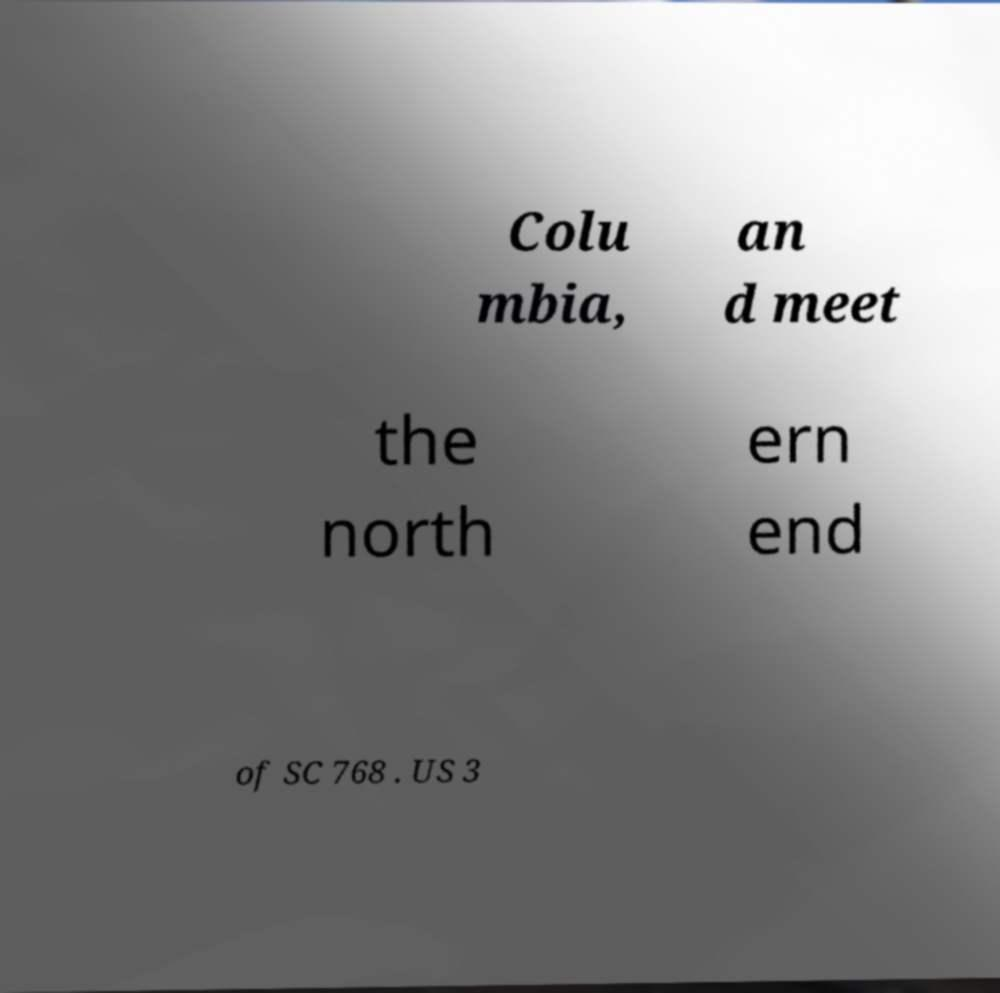Could you extract and type out the text from this image? Colu mbia, an d meet the north ern end of SC 768 . US 3 